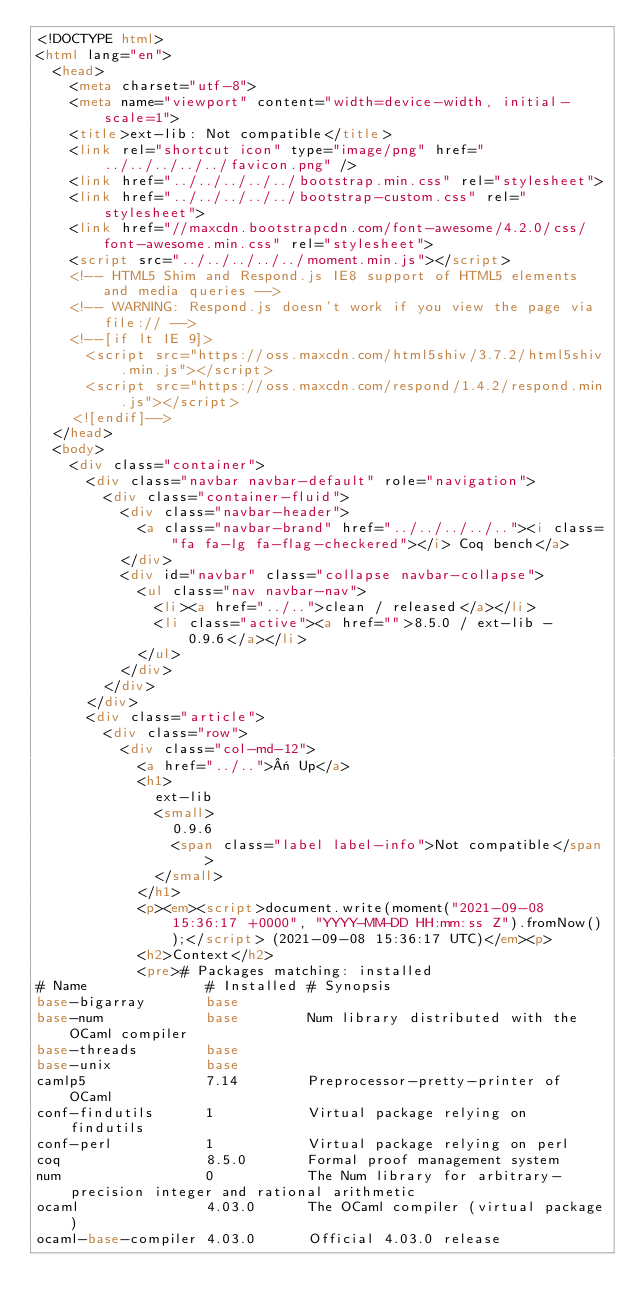Convert code to text. <code><loc_0><loc_0><loc_500><loc_500><_HTML_><!DOCTYPE html>
<html lang="en">
  <head>
    <meta charset="utf-8">
    <meta name="viewport" content="width=device-width, initial-scale=1">
    <title>ext-lib: Not compatible</title>
    <link rel="shortcut icon" type="image/png" href="../../../../../favicon.png" />
    <link href="../../../../../bootstrap.min.css" rel="stylesheet">
    <link href="../../../../../bootstrap-custom.css" rel="stylesheet">
    <link href="//maxcdn.bootstrapcdn.com/font-awesome/4.2.0/css/font-awesome.min.css" rel="stylesheet">
    <script src="../../../../../moment.min.js"></script>
    <!-- HTML5 Shim and Respond.js IE8 support of HTML5 elements and media queries -->
    <!-- WARNING: Respond.js doesn't work if you view the page via file:// -->
    <!--[if lt IE 9]>
      <script src="https://oss.maxcdn.com/html5shiv/3.7.2/html5shiv.min.js"></script>
      <script src="https://oss.maxcdn.com/respond/1.4.2/respond.min.js"></script>
    <![endif]-->
  </head>
  <body>
    <div class="container">
      <div class="navbar navbar-default" role="navigation">
        <div class="container-fluid">
          <div class="navbar-header">
            <a class="navbar-brand" href="../../../../.."><i class="fa fa-lg fa-flag-checkered"></i> Coq bench</a>
          </div>
          <div id="navbar" class="collapse navbar-collapse">
            <ul class="nav navbar-nav">
              <li><a href="../..">clean / released</a></li>
              <li class="active"><a href="">8.5.0 / ext-lib - 0.9.6</a></li>
            </ul>
          </div>
        </div>
      </div>
      <div class="article">
        <div class="row">
          <div class="col-md-12">
            <a href="../..">« Up</a>
            <h1>
              ext-lib
              <small>
                0.9.6
                <span class="label label-info">Not compatible</span>
              </small>
            </h1>
            <p><em><script>document.write(moment("2021-09-08 15:36:17 +0000", "YYYY-MM-DD HH:mm:ss Z").fromNow());</script> (2021-09-08 15:36:17 UTC)</em><p>
            <h2>Context</h2>
            <pre># Packages matching: installed
# Name              # Installed # Synopsis
base-bigarray       base
base-num            base        Num library distributed with the OCaml compiler
base-threads        base
base-unix           base
camlp5              7.14        Preprocessor-pretty-printer of OCaml
conf-findutils      1           Virtual package relying on findutils
conf-perl           1           Virtual package relying on perl
coq                 8.5.0       Formal proof management system
num                 0           The Num library for arbitrary-precision integer and rational arithmetic
ocaml               4.03.0      The OCaml compiler (virtual package)
ocaml-base-compiler 4.03.0      Official 4.03.0 release</code> 